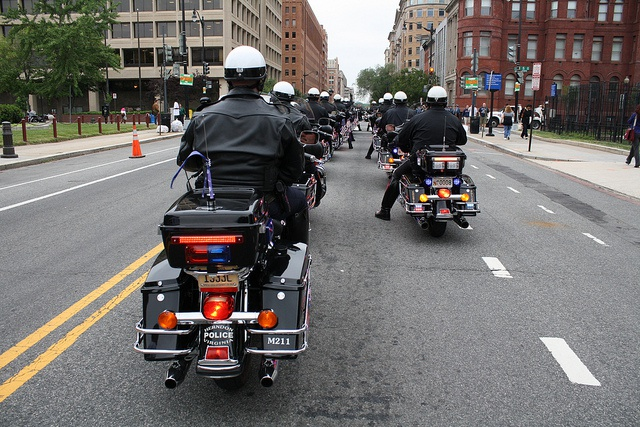Describe the objects in this image and their specific colors. I can see motorcycle in black, gray, darkblue, and darkgray tones, people in black, gray, and white tones, motorcycle in black, gray, darkgray, and lightgray tones, people in black, gray, lightgray, and darkgray tones, and motorcycle in black, gray, darkgray, and lightgray tones in this image. 